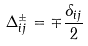Convert formula to latex. <formula><loc_0><loc_0><loc_500><loc_500>\Delta _ { i j } ^ { \pm } = \mp \frac { \delta _ { i j } } { 2 }</formula> 